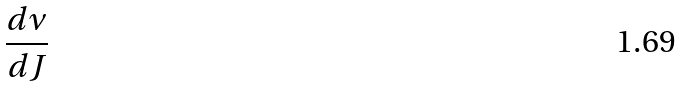Convert formula to latex. <formula><loc_0><loc_0><loc_500><loc_500>\frac { d \nu } { d J }</formula> 